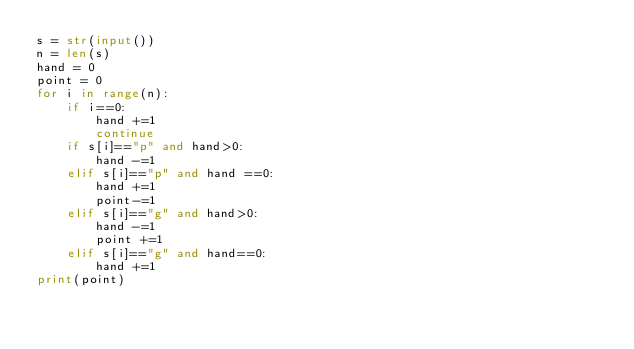Convert code to text. <code><loc_0><loc_0><loc_500><loc_500><_Python_>s = str(input())
n = len(s)
hand = 0
point = 0
for i in range(n):
    if i==0:
        hand +=1
        continue
    if s[i]=="p" and hand>0:
        hand -=1
    elif s[i]=="p" and hand ==0:
        hand +=1
        point-=1
    elif s[i]=="g" and hand>0:
        hand -=1
        point +=1
    elif s[i]=="g" and hand==0:
        hand +=1
print(point)
</code> 